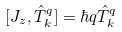<formula> <loc_0><loc_0><loc_500><loc_500>[ J _ { z } , \hat { T } _ { k } ^ { q } ] = \hbar { q } \hat { T } _ { k } ^ { q }</formula> 